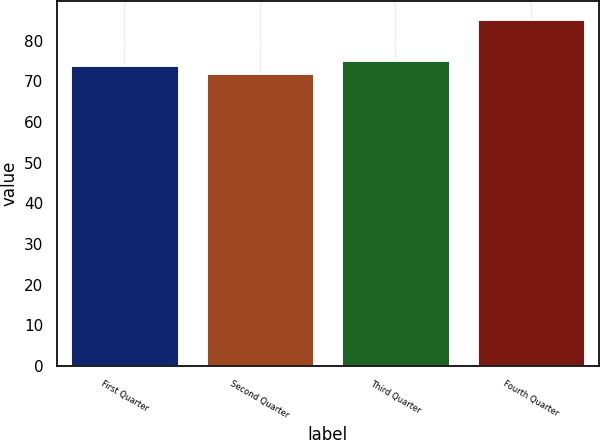Convert chart to OTSL. <chart><loc_0><loc_0><loc_500><loc_500><bar_chart><fcel>First Quarter<fcel>Second Quarter<fcel>Third Quarter<fcel>Fourth Quarter<nl><fcel>74.06<fcel>72.18<fcel>75.39<fcel>85.44<nl></chart> 